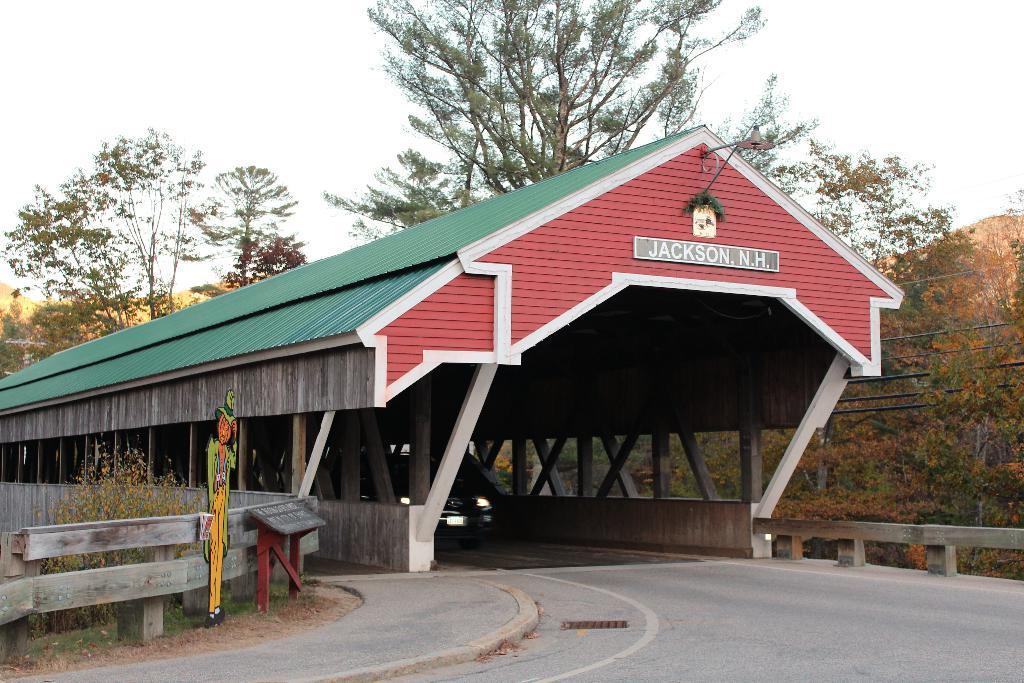What type of structure can be seen in the image? There is a shed in the image. What else is present in the image besides the shed? There is a vehicle, boards, a fence, plants, and trees visible in the image. Can you describe the vehicle in the image? The provided facts do not give specific details about the vehicle, so we cannot describe it further. What type of vegetation is present in the image? There are plants and trees visible in the image. What is visible in the background of the image? The sky is visible in the background of the image. What type of bead is used to decorate the fence in the image? There is no mention of beads or any decorative elements on the fence in the provided facts, so we cannot answer this question. Can you tell me how the power is generated for the vehicle in the image? The provided facts do not give any information about the vehicle's power source, so we cannot answer this question. 